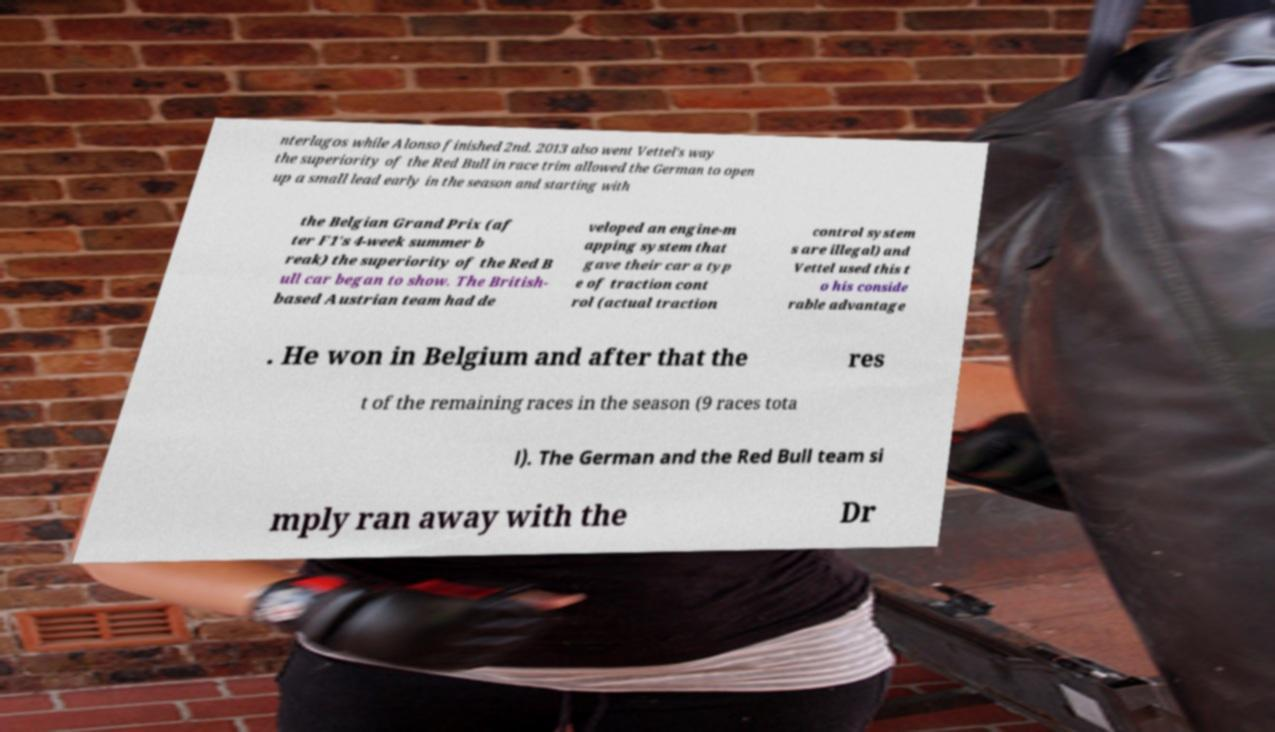I need the written content from this picture converted into text. Can you do that? nterlagos while Alonso finished 2nd. 2013 also went Vettel's way the superiority of the Red Bull in race trim allowed the German to open up a small lead early in the season and starting with the Belgian Grand Prix (af ter F1's 4-week summer b reak) the superiority of the Red B ull car began to show. The British- based Austrian team had de veloped an engine-m apping system that gave their car a typ e of traction cont rol (actual traction control system s are illegal) and Vettel used this t o his conside rable advantage . He won in Belgium and after that the res t of the remaining races in the season (9 races tota l). The German and the Red Bull team si mply ran away with the Dr 